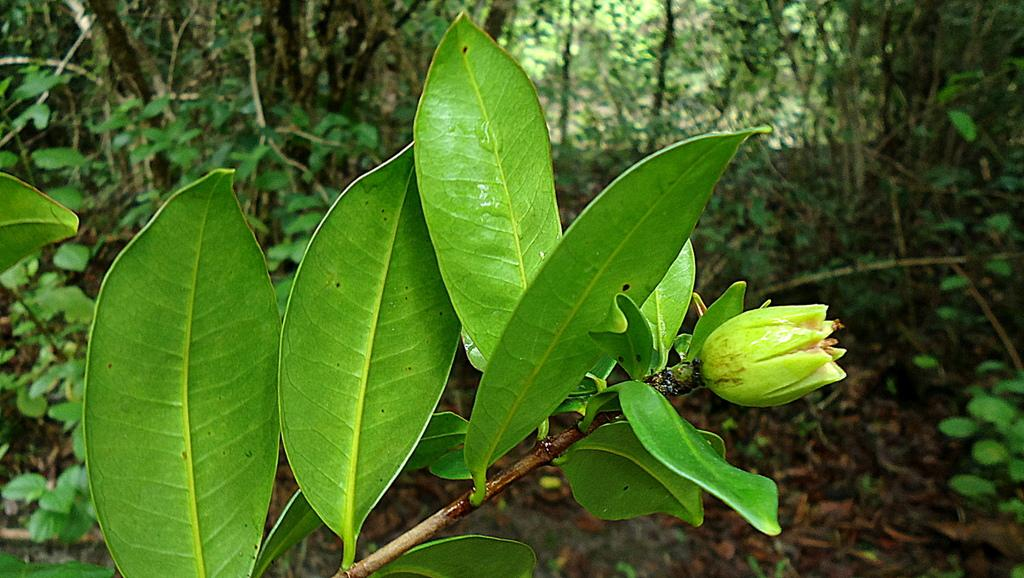What is the main subject of the image? There is a flower in the image. Can you describe the flower's structure? The flower has a stem and leaves. What can be seen in the background of the image? There are trees in the background of the image. What type of sea creature can be seen swimming near the flower in the image? There is no sea creature present in the image; it features a flower with a stem and leaves, and trees in the background. 